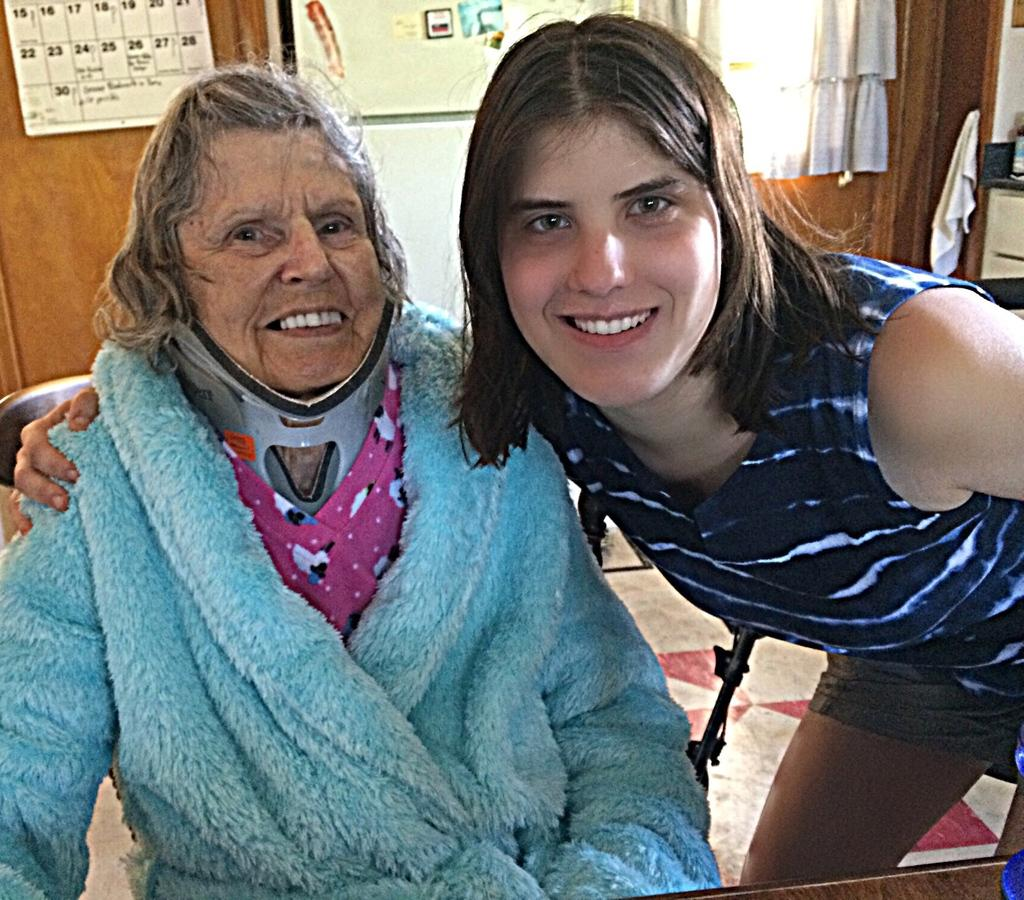What is the woman doing in the image? The woman is sitting on a chair in the image. Who is with the woman in the image? There is a girl standing beside the woman in the image. What can be seen on the backside of the image? There is a calendar, a board, a cloth, a curtain, and a wall on the backside in the image. What type of sofa is visible in the image? There is no sofa present in the image. What educational institution is the girl attending, as seen in the image? The image does not provide any information about the girl's education or the educational institution she might be attending. 